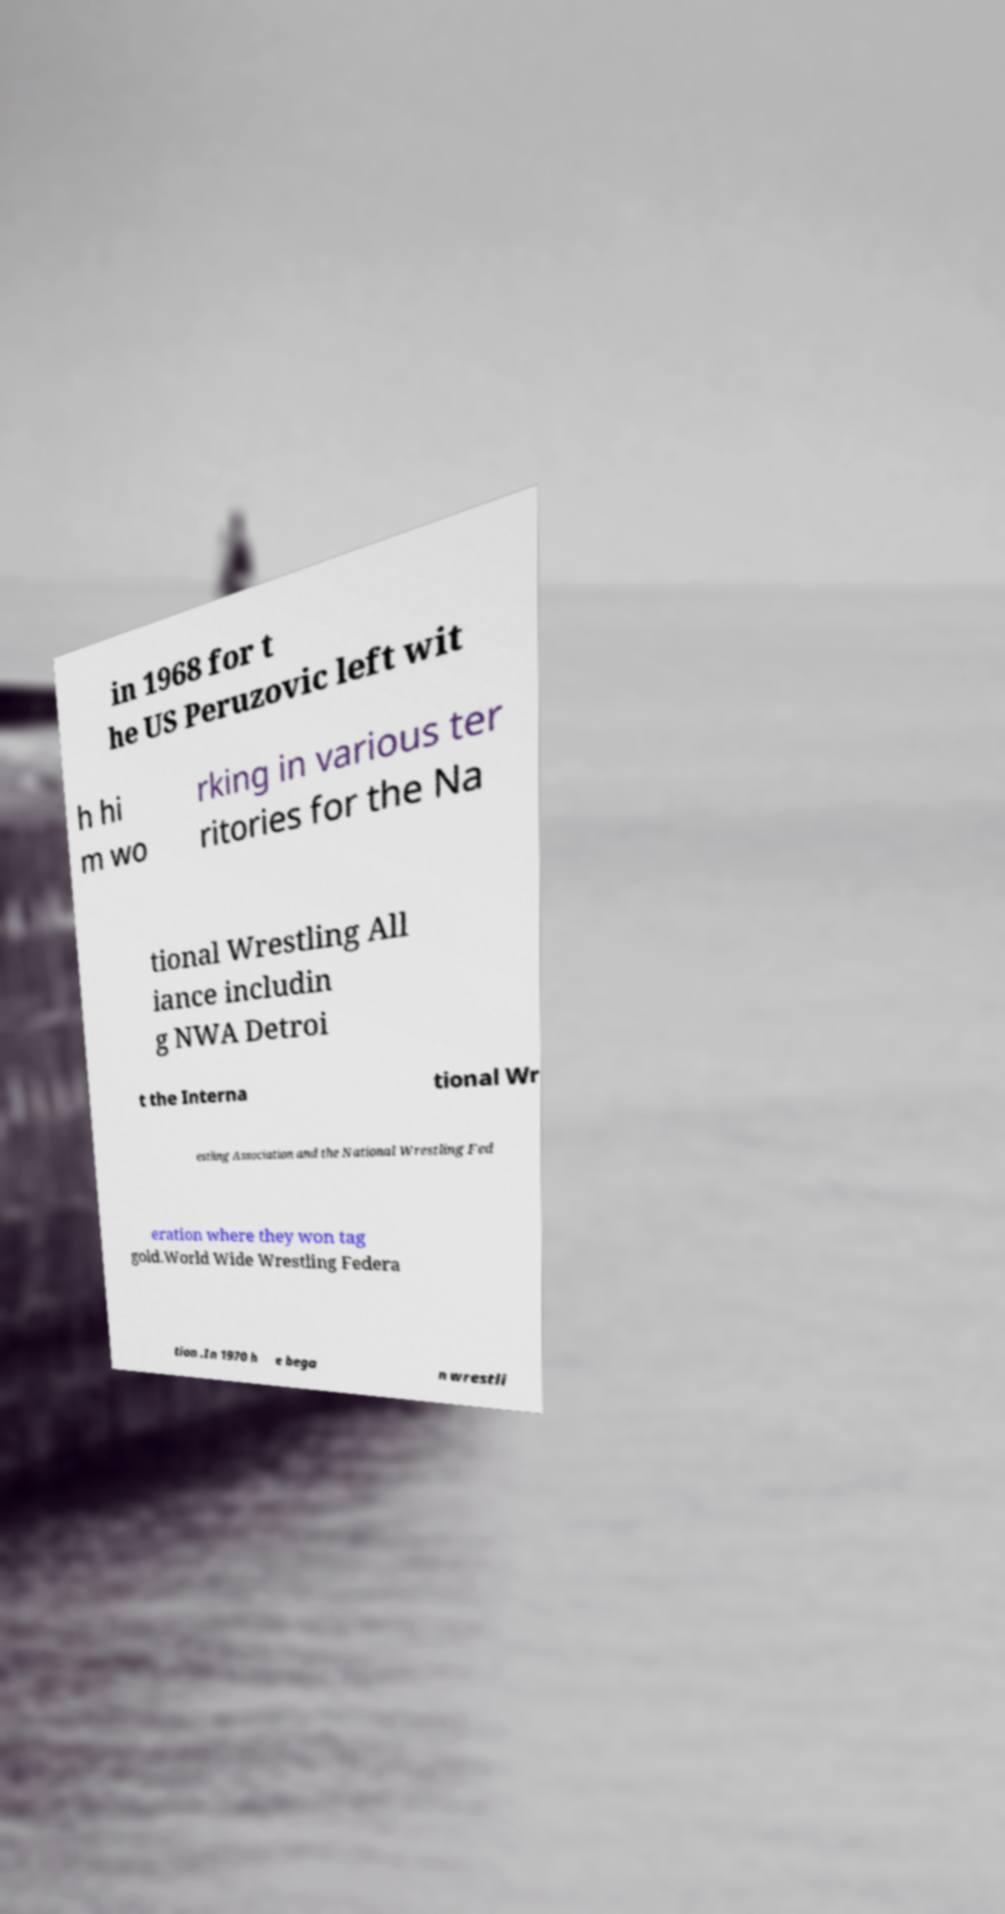Could you assist in decoding the text presented in this image and type it out clearly? in 1968 for t he US Peruzovic left wit h hi m wo rking in various ter ritories for the Na tional Wrestling All iance includin g NWA Detroi t the Interna tional Wr estling Association and the National Wrestling Fed eration where they won tag gold.World Wide Wrestling Federa tion .In 1970 h e bega n wrestli 